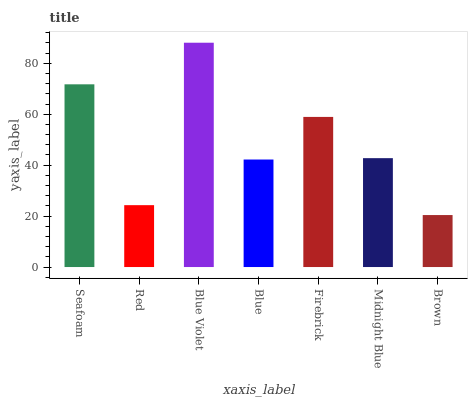Is Brown the minimum?
Answer yes or no. Yes. Is Blue Violet the maximum?
Answer yes or no. Yes. Is Red the minimum?
Answer yes or no. No. Is Red the maximum?
Answer yes or no. No. Is Seafoam greater than Red?
Answer yes or no. Yes. Is Red less than Seafoam?
Answer yes or no. Yes. Is Red greater than Seafoam?
Answer yes or no. No. Is Seafoam less than Red?
Answer yes or no. No. Is Midnight Blue the high median?
Answer yes or no. Yes. Is Midnight Blue the low median?
Answer yes or no. Yes. Is Brown the high median?
Answer yes or no. No. Is Seafoam the low median?
Answer yes or no. No. 